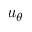<formula> <loc_0><loc_0><loc_500><loc_500>u _ { \theta }</formula> 